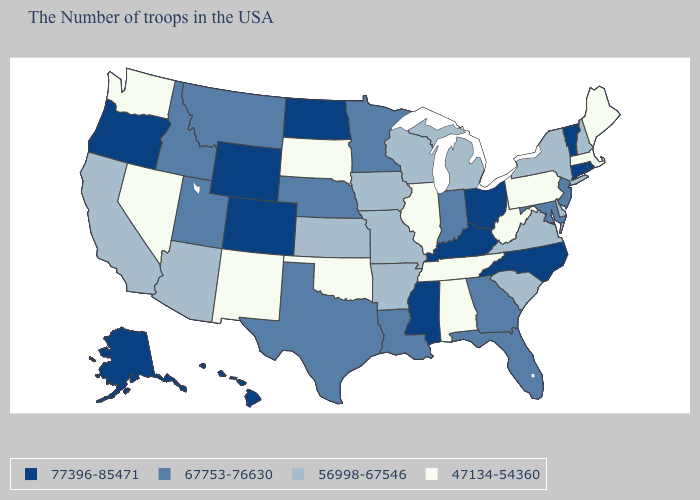Name the states that have a value in the range 56998-67546?
Concise answer only. New Hampshire, New York, Delaware, Virginia, South Carolina, Michigan, Wisconsin, Missouri, Arkansas, Iowa, Kansas, Arizona, California. Name the states that have a value in the range 56998-67546?
Concise answer only. New Hampshire, New York, Delaware, Virginia, South Carolina, Michigan, Wisconsin, Missouri, Arkansas, Iowa, Kansas, Arizona, California. How many symbols are there in the legend?
Write a very short answer. 4. What is the value of Oklahoma?
Short answer required. 47134-54360. Name the states that have a value in the range 77396-85471?
Quick response, please. Rhode Island, Vermont, Connecticut, North Carolina, Ohio, Kentucky, Mississippi, North Dakota, Wyoming, Colorado, Oregon, Alaska, Hawaii. Which states have the lowest value in the West?
Be succinct. New Mexico, Nevada, Washington. Is the legend a continuous bar?
Concise answer only. No. What is the value of Illinois?
Short answer required. 47134-54360. Is the legend a continuous bar?
Be succinct. No. Is the legend a continuous bar?
Short answer required. No. What is the value of Kansas?
Quick response, please. 56998-67546. Does Washington have the highest value in the USA?
Short answer required. No. What is the value of Utah?
Keep it brief. 67753-76630. Is the legend a continuous bar?
Give a very brief answer. No. Name the states that have a value in the range 67753-76630?
Give a very brief answer. New Jersey, Maryland, Florida, Georgia, Indiana, Louisiana, Minnesota, Nebraska, Texas, Utah, Montana, Idaho. 